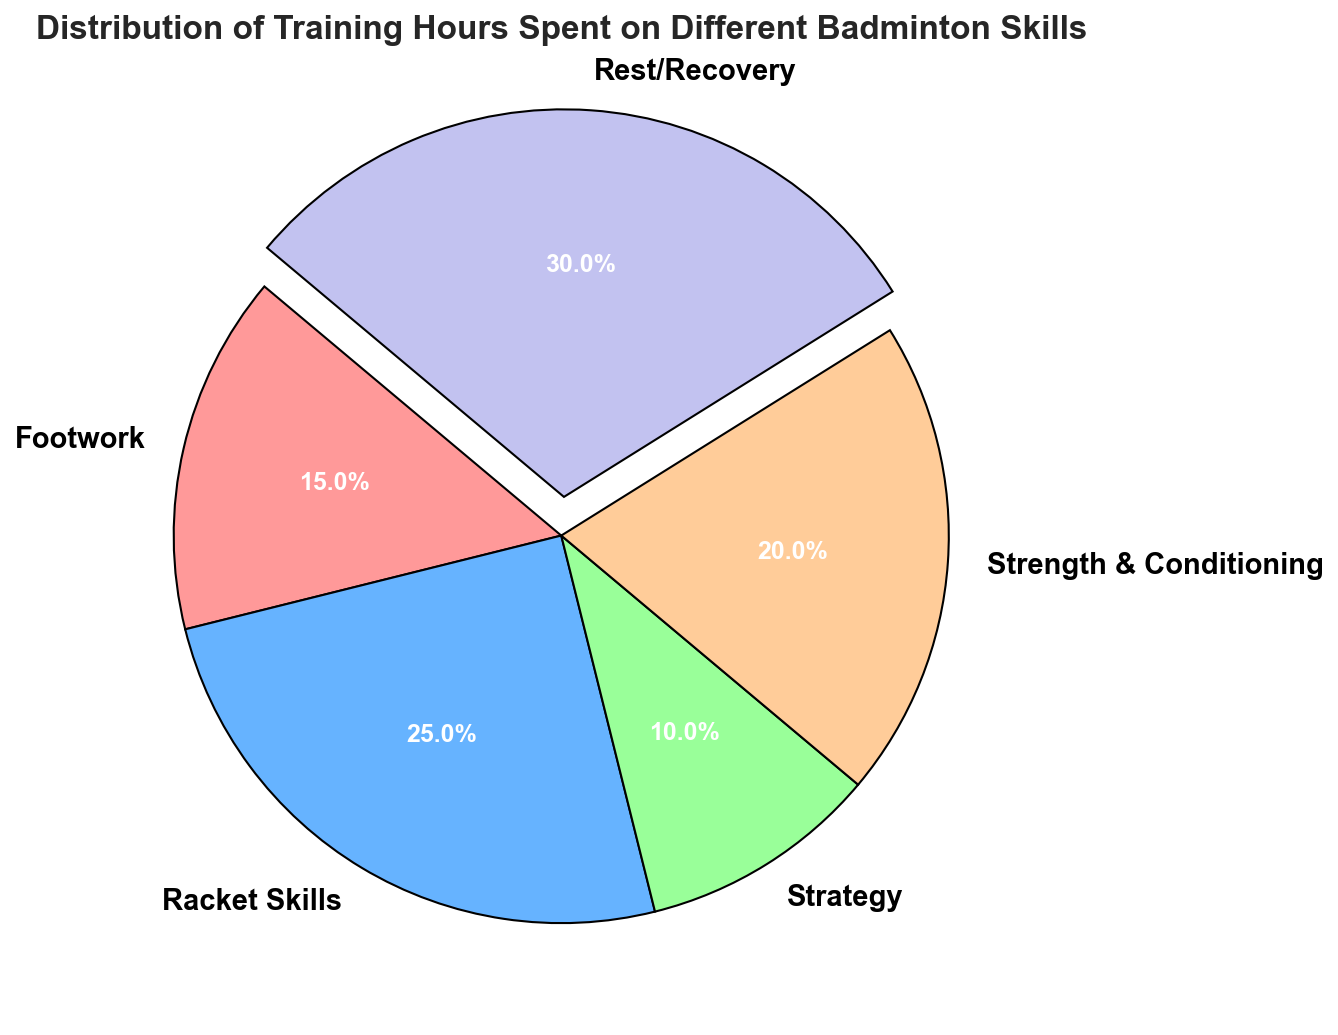Which skill has the highest percentage of training hours? The skill with the highest percentage will be the one with the largest slice in the pie chart. The 'Rest/Recovery' has the largest slice which is highlighted by an exploded section.
Answer: Rest/Recovery Which skill occupies the smallest percentage of total training hours? The skill with the smallest percentage will have the smallest slice in the pie chart. The 'Strategy' slice is the smallest.
Answer: Strategy How many more hours are spent on racket skills compared to strategy? From the data, racket skills have 25 hours and strategy has 10 hours. The difference is calculated by subtracting 10 from 25.
Answer: 15 hours Are more hours spent on rest/recovery than on strength & conditioning? Comparing the slices for 'Rest/Recovery' and 'Strength & Conditioning', 'Rest/Recovery' is larger.
Answer: Yes What is the combined percentage of training hours spent on footwork and strategy? From the pie chart percentages, add up the percentages for 'Footwork' and 'Strategy'. 'Footwork' is 15 hours and 'Strategy' is 10 hours, making the combined total 25 hours. As the total hours are 100, the combined percentage is 25%.
Answer: 25% What percentage of the training hours is devoted to strength & conditioning? This is indicated by the slice size in the pie chart, which is labeled. According to the pie chart, strength & conditioning takes 20% of the total.
Answer: 20% How much more percentage of training time is allocated to racket skills compared to footwork? Find the slices for 'Racket Skills' and 'Footwork'. 'Racket Skills' is 25% and 'Footwork' is 15%, so 25% - 15% = 10%.
Answer: 10% What is the average number of training hours allocated per skill? Add up all the hours and divide by the number of skills. Total is 100 hours over 5 skills, hence average is 100/5 = 20 hours.
Answer: 20 hours Are strategy and strength & conditioning allocated the same amount of time? Compare the slices labeled 'Strategy' and 'Strength & Conditioning'. Strategy is 10 hours and strength & conditioning is 20 hours, so they are not the same.
Answer: No What is the total number of training hours spent on racket skills and strength & conditioning combined? Sum the hours dedicated to 'Racket Skills' and 'Strength & Conditioning'. 25 hours for racket skills + 20 hours for strength & conditioning = 45 hours.
Answer: 45 hours 